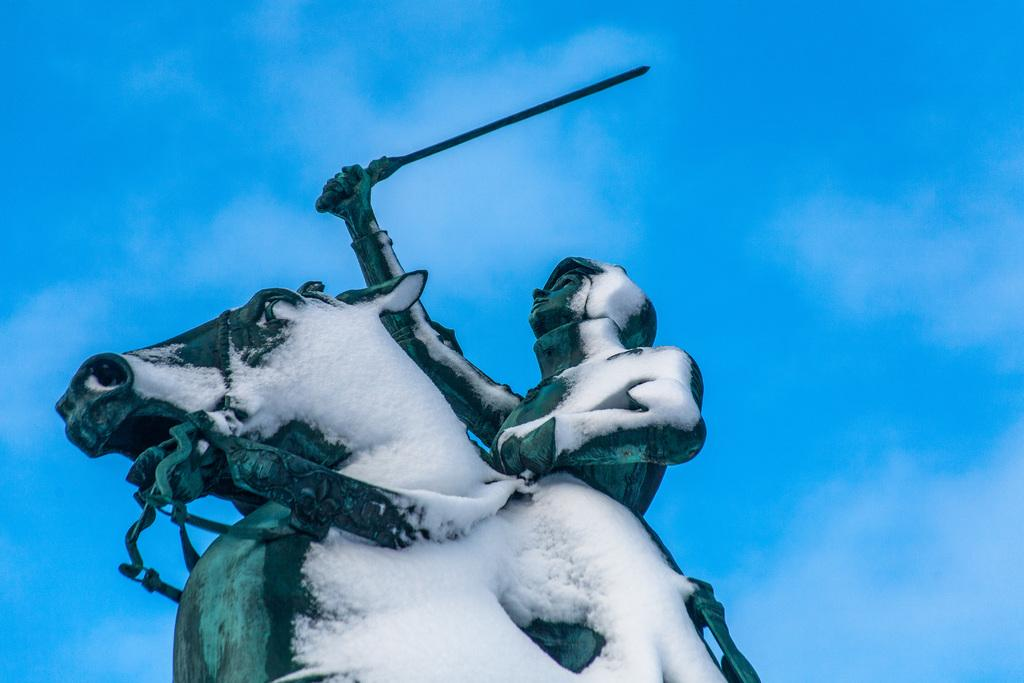What is the main subject of the image? The main subject of the image is a sculpture of a person and horse. What material is the sculpture made of? The sculpture is made of snow. What can be seen in the background of the image? There is a sky visible in the image. What object is present in the image that is not part of the sculpture? There is a sword in the image. How does the goose interact with the sculpture in the image? There is no goose present in the image, so it cannot interact with the sculpture. What type of home is depicted in the image? There is no home depicted in the image; it features a sculpture of a person and horse, a sword, and a sky. 